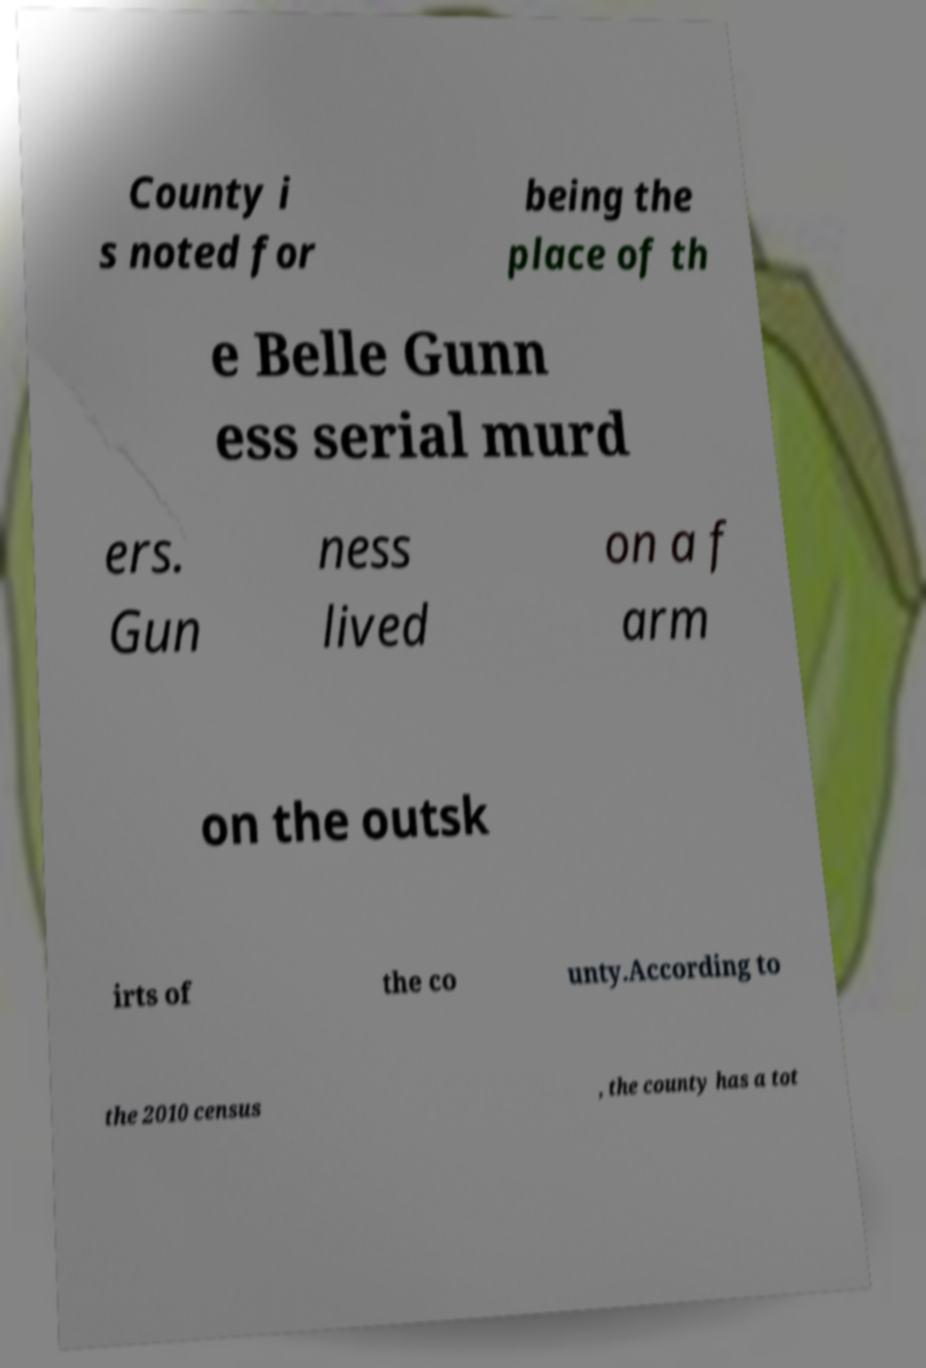Please read and relay the text visible in this image. What does it say? County i s noted for being the place of th e Belle Gunn ess serial murd ers. Gun ness lived on a f arm on the outsk irts of the co unty.According to the 2010 census , the county has a tot 